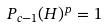<formula> <loc_0><loc_0><loc_500><loc_500>P _ { c - 1 } ( H ) ^ { p } = 1</formula> 